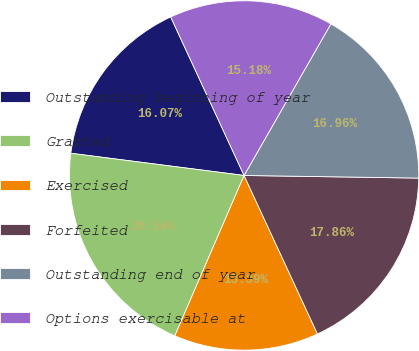Convert chart to OTSL. <chart><loc_0><loc_0><loc_500><loc_500><pie_chart><fcel>Outstanding beginning of year<fcel>Granted<fcel>Exercised<fcel>Forfeited<fcel>Outstanding end of year<fcel>Options exercisable at<nl><fcel>16.07%<fcel>20.54%<fcel>13.39%<fcel>17.86%<fcel>16.96%<fcel>15.18%<nl></chart> 